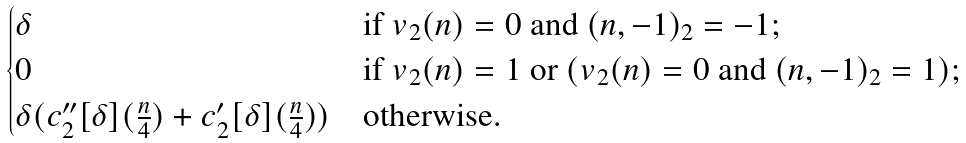Convert formula to latex. <formula><loc_0><loc_0><loc_500><loc_500>\begin{cases} \delta & \text {if } v _ { 2 } ( n ) = 0 \text { and } ( n , - 1 ) _ { 2 } = - 1 ; \\ 0 & \text {if } v _ { 2 } ( n ) = 1 \text { or } ( v _ { 2 } ( n ) = 0 \text { and } ( n , - 1 ) _ { 2 } = 1 ) ; \\ \delta ( c _ { 2 } ^ { \prime \prime } [ \delta ] ( \frac { n } { 4 } ) + c _ { 2 } ^ { \prime } [ \delta ] ( \frac { n } { 4 } ) ) & \text {otherwise.} \end{cases}</formula> 